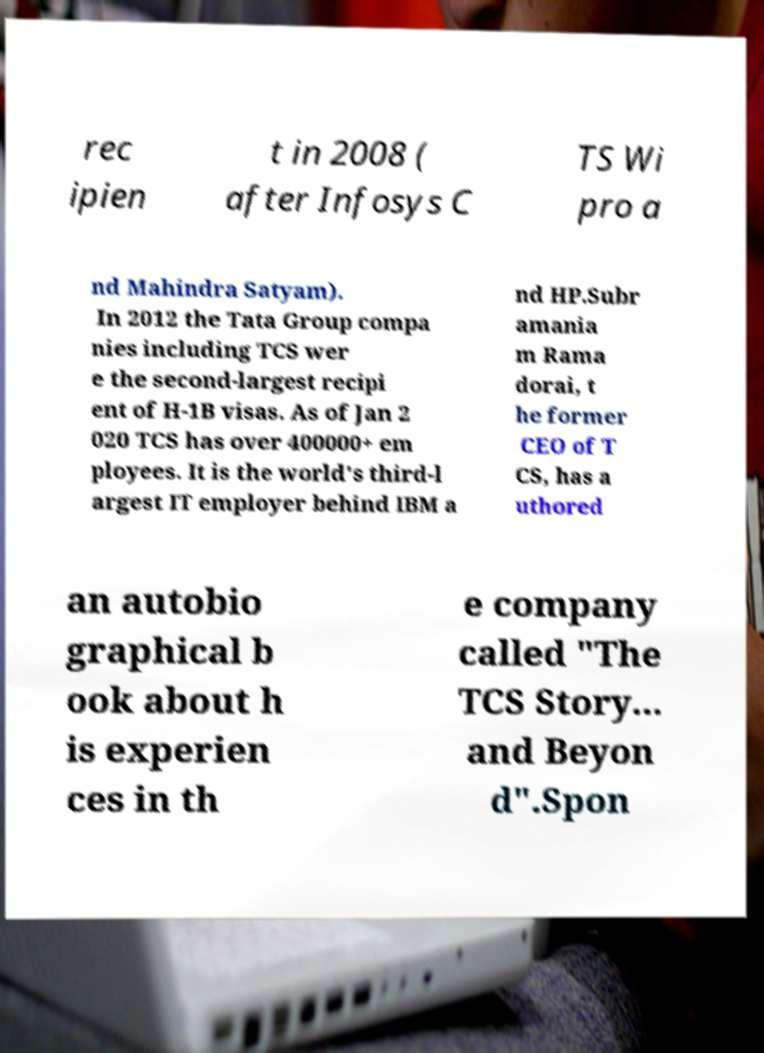I need the written content from this picture converted into text. Can you do that? rec ipien t in 2008 ( after Infosys C TS Wi pro a nd Mahindra Satyam). In 2012 the Tata Group compa nies including TCS wer e the second-largest recipi ent of H-1B visas. As of Jan 2 020 TCS has over 400000+ em ployees. It is the world's third-l argest IT employer behind IBM a nd HP.Subr amania m Rama dorai, t he former CEO of T CS, has a uthored an autobio graphical b ook about h is experien ces in th e company called "The TCS Story... and Beyon d".Spon 